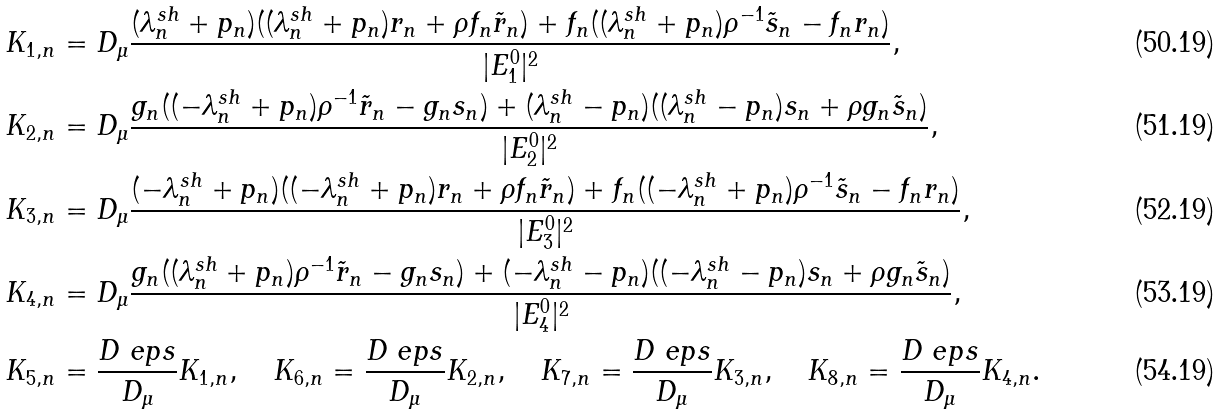Convert formula to latex. <formula><loc_0><loc_0><loc_500><loc_500>K _ { 1 , n } & = D _ { \mu } \frac { ( \lambda _ { n } ^ { s h } + p _ { n } ) ( ( \lambda _ { n } ^ { s h } + p _ { n } ) r _ { n } + \rho f _ { n } \tilde { r } _ { n } ) + f _ { n } ( ( \lambda _ { n } ^ { s h } + p _ { n } ) \rho ^ { - 1 } \tilde { s } _ { n } - f _ { n } r _ { n } ) } { | E ^ { 0 } _ { 1 } | ^ { 2 } } , \\ K _ { 2 , n } & = D _ { \mu } \frac { g _ { n } ( ( - \lambda _ { n } ^ { s h } + p _ { n } ) \rho ^ { - 1 } \tilde { r } _ { n } - g _ { n } s _ { n } ) + ( \lambda _ { n } ^ { s h } - p _ { n } ) ( ( \lambda _ { n } ^ { s h } - p _ { n } ) s _ { n } + \rho g _ { n } \tilde { s } _ { n } ) } { | E ^ { 0 } _ { 2 } | ^ { 2 } } , \\ K _ { 3 , n } & = D _ { \mu } \frac { ( - \lambda _ { n } ^ { s h } + p _ { n } ) ( ( - \lambda _ { n } ^ { s h } + p _ { n } ) r _ { n } + \rho f _ { n } \tilde { r } _ { n } ) + f _ { n } ( ( - \lambda _ { n } ^ { s h } + p _ { n } ) \rho ^ { - 1 } \tilde { s } _ { n } - f _ { n } r _ { n } ) } { | E ^ { 0 } _ { 3 } | ^ { 2 } } , \\ K _ { 4 , n } & = D _ { \mu } \frac { g _ { n } ( ( \lambda _ { n } ^ { s h } + p _ { n } ) \rho ^ { - 1 } \tilde { r } _ { n } - g _ { n } s _ { n } ) + ( - \lambda _ { n } ^ { s h } - p _ { n } ) ( ( - \lambda _ { n } ^ { s h } - p _ { n } ) s _ { n } + \rho g _ { n } \tilde { s } _ { n } ) } { | E ^ { 0 } _ { 4 } | ^ { 2 } } , \\ K _ { 5 , n } & = \frac { D _ { \ } e p s } { D _ { \mu } } K _ { 1 , n } , \quad K _ { 6 , n } = \frac { D _ { \ } e p s } { D _ { \mu } } K _ { 2 , n } , \quad K _ { 7 , n } = \frac { D _ { \ } e p s } { D _ { \mu } } K _ { 3 , n } , \quad K _ { 8 , n } = \frac { D _ { \ } e p s } { D _ { \mu } } K _ { 4 , n } .</formula> 